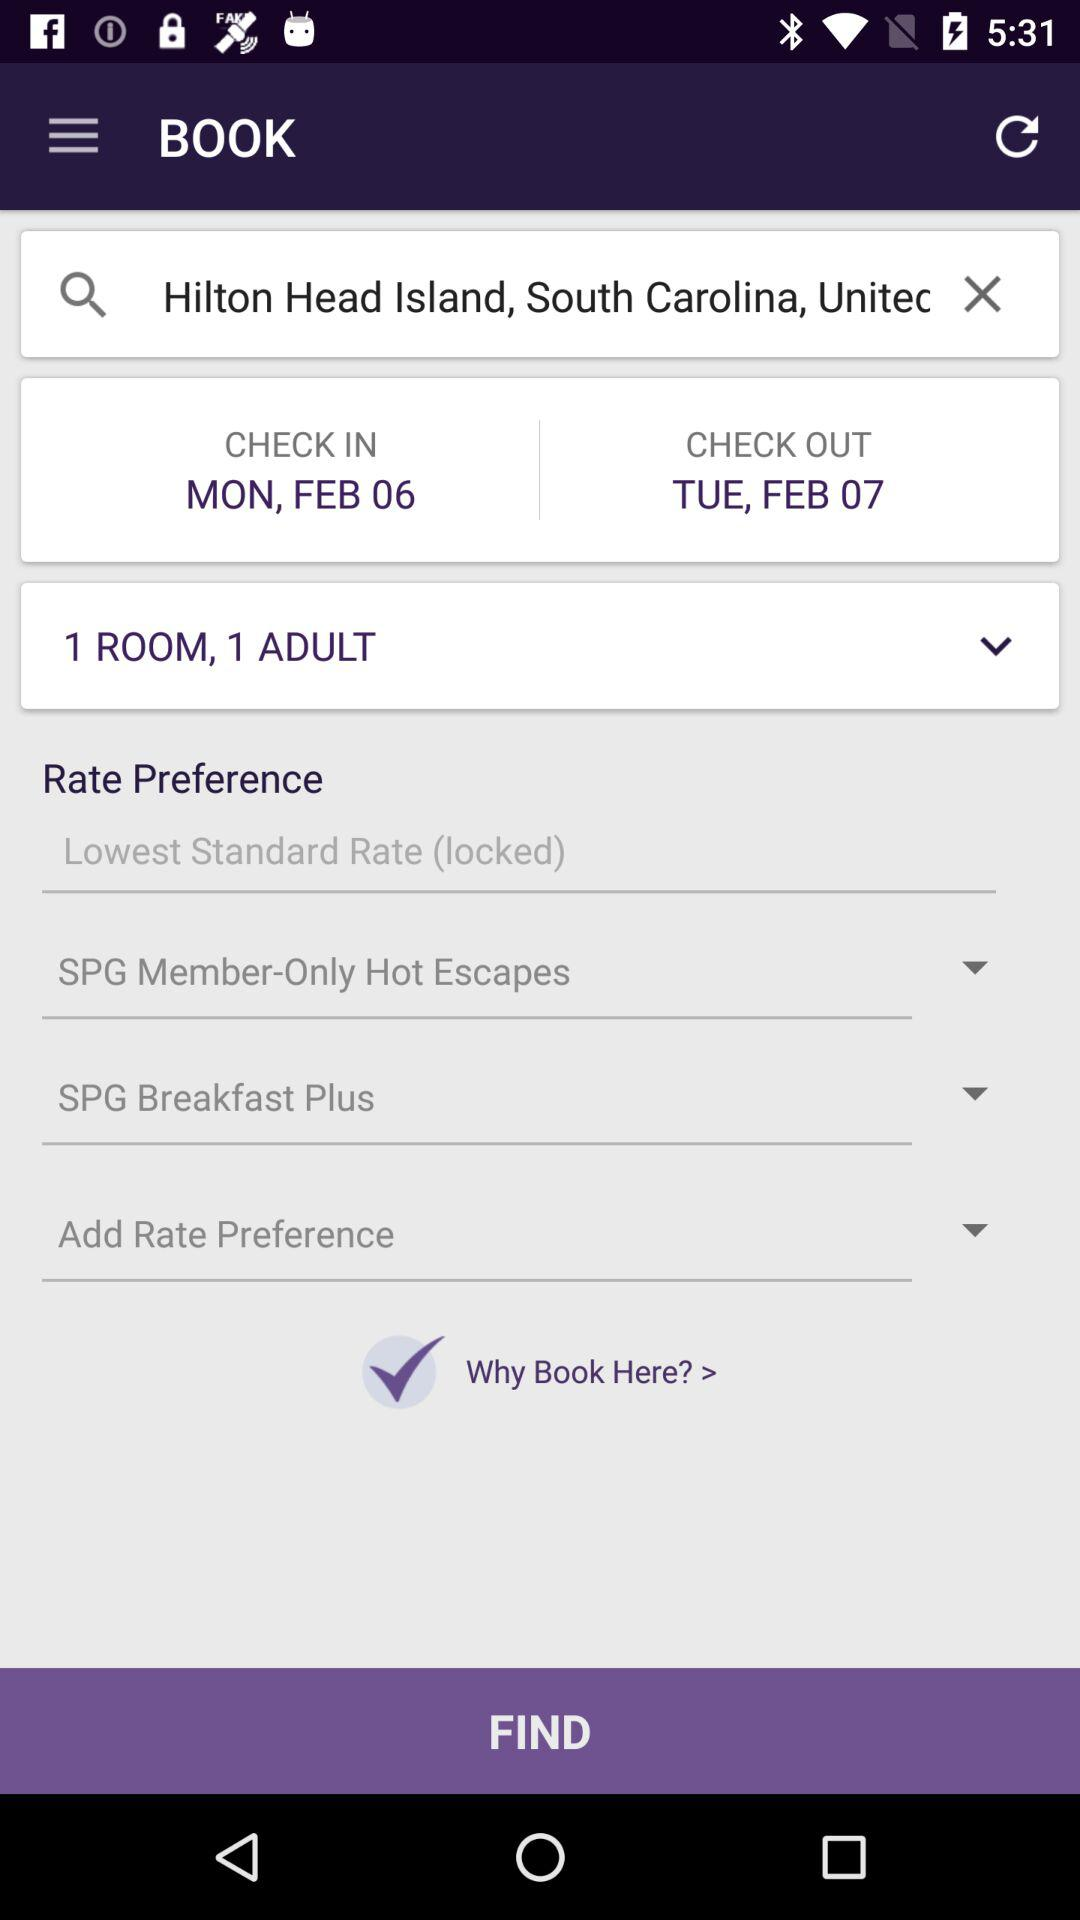What is the day on February 7? The day is Tuesday. 